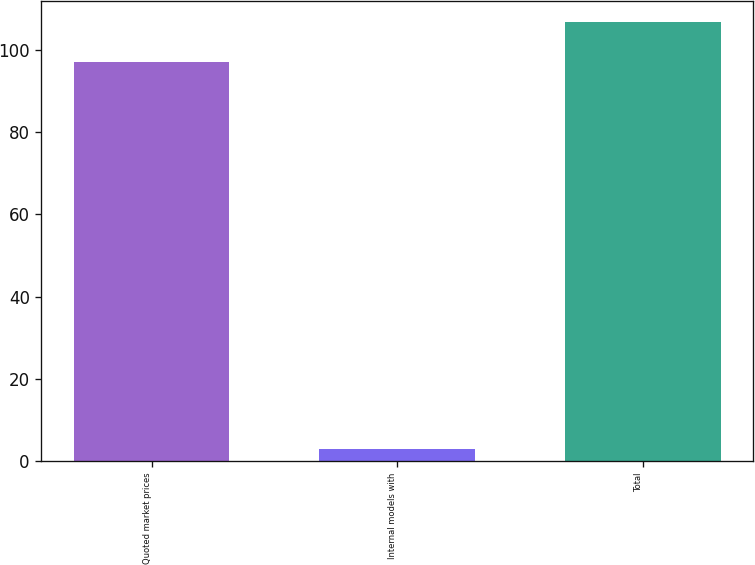Convert chart. <chart><loc_0><loc_0><loc_500><loc_500><bar_chart><fcel>Quoted market prices<fcel>Internal models with<fcel>Total<nl><fcel>97<fcel>3<fcel>106.7<nl></chart> 